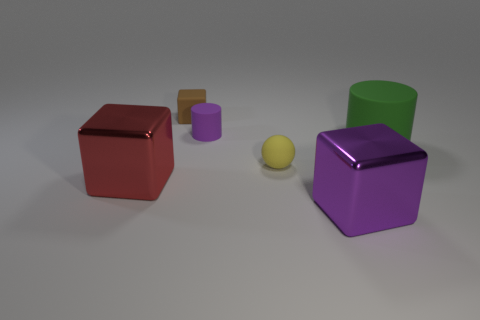Are there fewer tiny brown cubes in front of the red thing than large purple objects that are left of the small cylinder?
Give a very brief answer. No. Does the red object have the same size as the matte cylinder to the right of the tiny yellow rubber object?
Offer a very short reply. Yes. What number of green cylinders are the same size as the purple cylinder?
Your response must be concise. 0. How many large things are either brown blocks or cyan shiny objects?
Make the answer very short. 0. Are any small cyan things visible?
Give a very brief answer. No. Is the number of large rubber cylinders that are in front of the big cylinder greater than the number of tiny brown objects that are behind the small brown rubber cube?
Provide a succinct answer. No. The cube behind the tiny object that is to the right of the purple cylinder is what color?
Offer a terse response. Brown. Are there any big shiny objects of the same color as the large rubber thing?
Give a very brief answer. No. How big is the thing that is to the right of the shiny block that is in front of the thing that is left of the small rubber block?
Offer a very short reply. Large. There is a tiny brown object; what shape is it?
Offer a very short reply. Cube. 